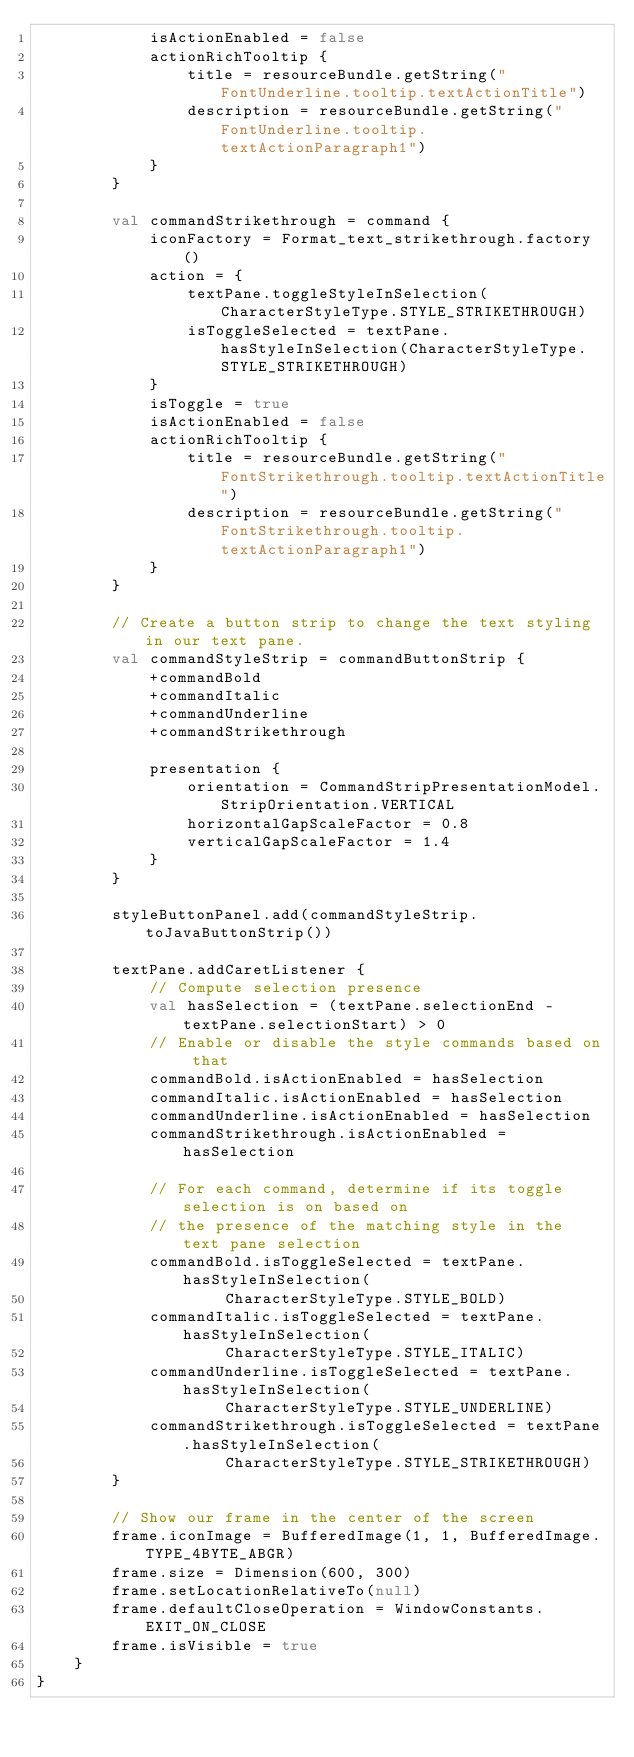Convert code to text. <code><loc_0><loc_0><loc_500><loc_500><_Kotlin_>            isActionEnabled = false
            actionRichTooltip {
                title = resourceBundle.getString("FontUnderline.tooltip.textActionTitle")
                description = resourceBundle.getString("FontUnderline.tooltip.textActionParagraph1")
            }
        }

        val commandStrikethrough = command {
            iconFactory = Format_text_strikethrough.factory()
            action = {
                textPane.toggleStyleInSelection(CharacterStyleType.STYLE_STRIKETHROUGH)
                isToggleSelected = textPane.hasStyleInSelection(CharacterStyleType.STYLE_STRIKETHROUGH)
            }
            isToggle = true
            isActionEnabled = false
            actionRichTooltip {
                title = resourceBundle.getString("FontStrikethrough.tooltip.textActionTitle")
                description = resourceBundle.getString("FontStrikethrough.tooltip.textActionParagraph1")
            }
        }

        // Create a button strip to change the text styling in our text pane.
        val commandStyleStrip = commandButtonStrip {
            +commandBold
            +commandItalic
            +commandUnderline
            +commandStrikethrough

            presentation {
                orientation = CommandStripPresentationModel.StripOrientation.VERTICAL
                horizontalGapScaleFactor = 0.8
                verticalGapScaleFactor = 1.4
            }
        }

        styleButtonPanel.add(commandStyleStrip.toJavaButtonStrip())

        textPane.addCaretListener {
            // Compute selection presence
            val hasSelection = (textPane.selectionEnd - textPane.selectionStart) > 0
            // Enable or disable the style commands based on that
            commandBold.isActionEnabled = hasSelection
            commandItalic.isActionEnabled = hasSelection
            commandUnderline.isActionEnabled = hasSelection
            commandStrikethrough.isActionEnabled = hasSelection

            // For each command, determine if its toggle selection is on based on
            // the presence of the matching style in the text pane selection
            commandBold.isToggleSelected = textPane.hasStyleInSelection(
                    CharacterStyleType.STYLE_BOLD)
            commandItalic.isToggleSelected = textPane.hasStyleInSelection(
                    CharacterStyleType.STYLE_ITALIC)
            commandUnderline.isToggleSelected = textPane.hasStyleInSelection(
                    CharacterStyleType.STYLE_UNDERLINE)
            commandStrikethrough.isToggleSelected = textPane.hasStyleInSelection(
                    CharacterStyleType.STYLE_STRIKETHROUGH)
        }

        // Show our frame in the center of the screen
        frame.iconImage = BufferedImage(1, 1, BufferedImage.TYPE_4BYTE_ABGR)
        frame.size = Dimension(600, 300)
        frame.setLocationRelativeTo(null)
        frame.defaultCloseOperation = WindowConstants.EXIT_ON_CLOSE
        frame.isVisible = true
    }
}
</code> 